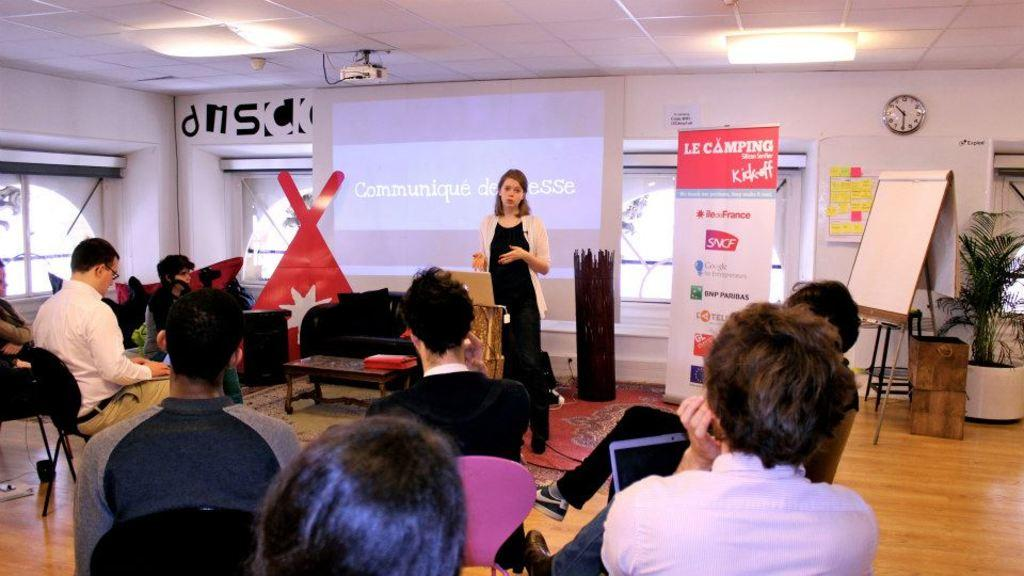What type of structure can be seen in the image? There is a wall in the image. What is a feature of the wall that allows for visibility outside? There is a window in the image. What device is present for displaying information or media? There is a screen in the image. What type of plant is visible in the image? There is a plant in the image. What is a surface for displaying or writing on in the image? There is a board in the image. What is a decorative or informative piece of fabric in the image? There is a banner in the image. Who or what is present in the image? There are people in the image. What type of seating is available in the image? There are chairs in the image. What type of seating is available for multiple people in the image? There is a sofa in the image. What type of surface is present for placing objects or serving food in the image? There is a table in the image. What device is present for projecting images or videos in the image? There is a projector in the image. What type of precipitation can be seen falling from the sky in the image? There is no precipitation visible in the image. What type of utensil is used for whipping ingredients in the image? There are no utensils or ingredients present in the image. How many cats are visible in the image? There are no cats present in the image. 